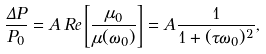Convert formula to latex. <formula><loc_0><loc_0><loc_500><loc_500>\frac { \Delta P } { P _ { 0 } } = A \, R e \left [ \frac { \mu _ { 0 } } { \mu ( \omega _ { 0 } ) } \right ] = A \frac { 1 } { 1 + ( \tau \omega _ { 0 } ) ^ { 2 } } ,</formula> 